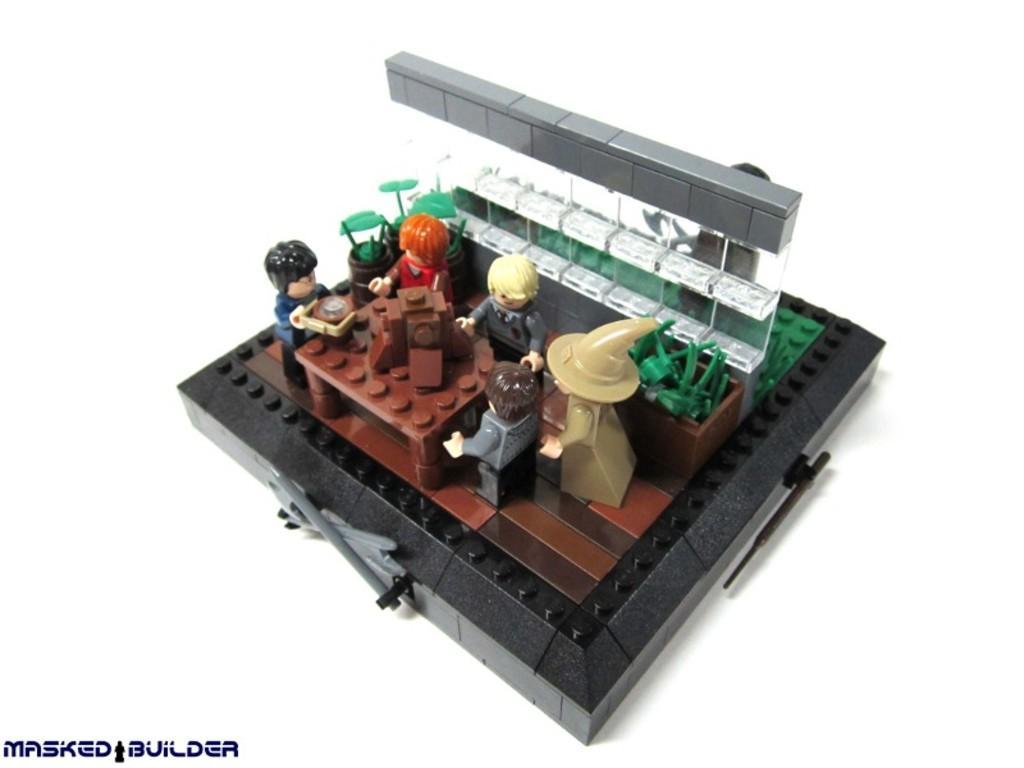Describe this image in one or two sentences. This picture shows a toy made by a building blocks and we see text on the bottom left corner. 